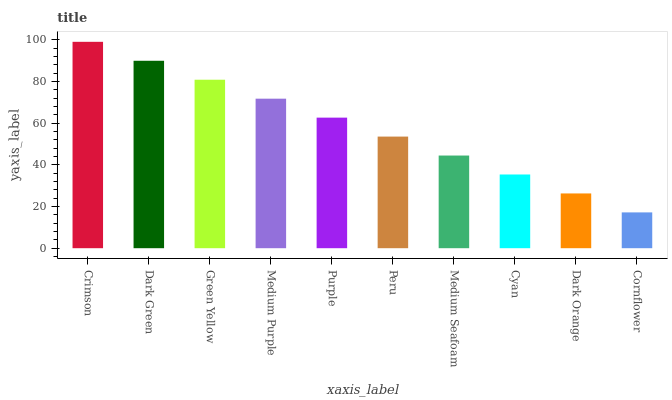Is Cornflower the minimum?
Answer yes or no. Yes. Is Crimson the maximum?
Answer yes or no. Yes. Is Dark Green the minimum?
Answer yes or no. No. Is Dark Green the maximum?
Answer yes or no. No. Is Crimson greater than Dark Green?
Answer yes or no. Yes. Is Dark Green less than Crimson?
Answer yes or no. Yes. Is Dark Green greater than Crimson?
Answer yes or no. No. Is Crimson less than Dark Green?
Answer yes or no. No. Is Purple the high median?
Answer yes or no. Yes. Is Peru the low median?
Answer yes or no. Yes. Is Cornflower the high median?
Answer yes or no. No. Is Purple the low median?
Answer yes or no. No. 